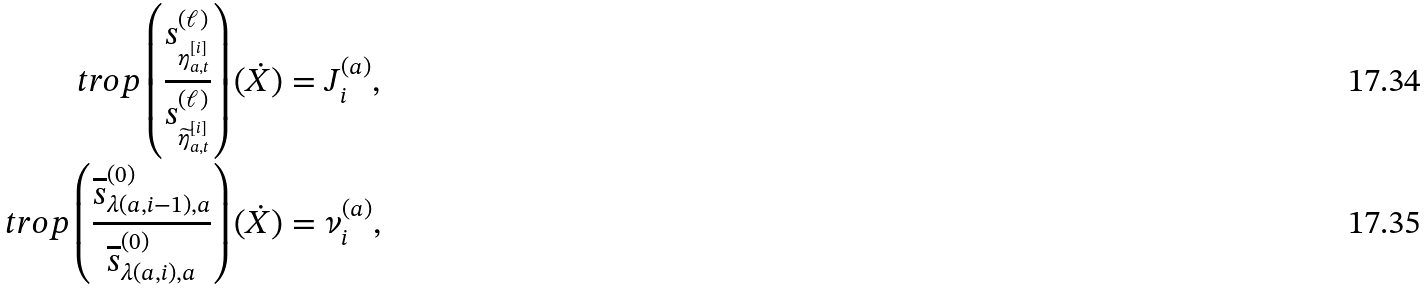<formula> <loc_0><loc_0><loc_500><loc_500>\ t r o p \left ( \frac { s ^ { ( \ell ) } _ { \eta _ { a , t } ^ { [ i ] } } } { s ^ { ( \ell ) } _ { \widetilde { \eta } _ { a , t } ^ { [ i ] } } } \right ) ( \dot { X } ) & = J _ { i } ^ { ( a ) } , \\ \ t r o p \left ( \frac { \overline { s } ^ { ( 0 ) } _ { \lambda ( a , i - 1 ) , a } } { \overline { s } ^ { ( 0 ) } _ { \lambda ( a , i ) , a } } \right ) ( \dot { X } ) & = \nu _ { i } ^ { ( a ) } ,</formula> 